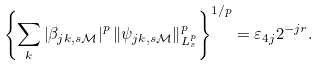<formula> <loc_0><loc_0><loc_500><loc_500>\left \{ \sum _ { k } \left | \beta _ { j k , s \mathcal { M } } \right | ^ { p } \left \| \psi _ { j k , s \mathcal { M } } \right \| _ { L _ { s } ^ { p } } ^ { p } \right \} ^ { 1 / p } = \varepsilon _ { 4 j } 2 ^ { - j r } .</formula> 